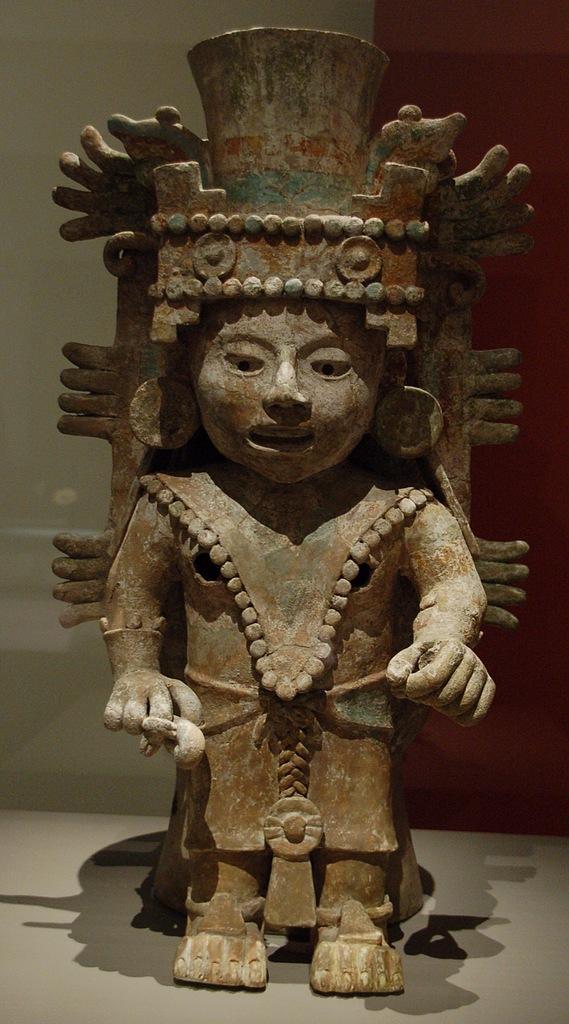Describe this image in one or two sentences. In this image in the center there is one statue, at the bottom there is a floor and in the background there is a wall. 